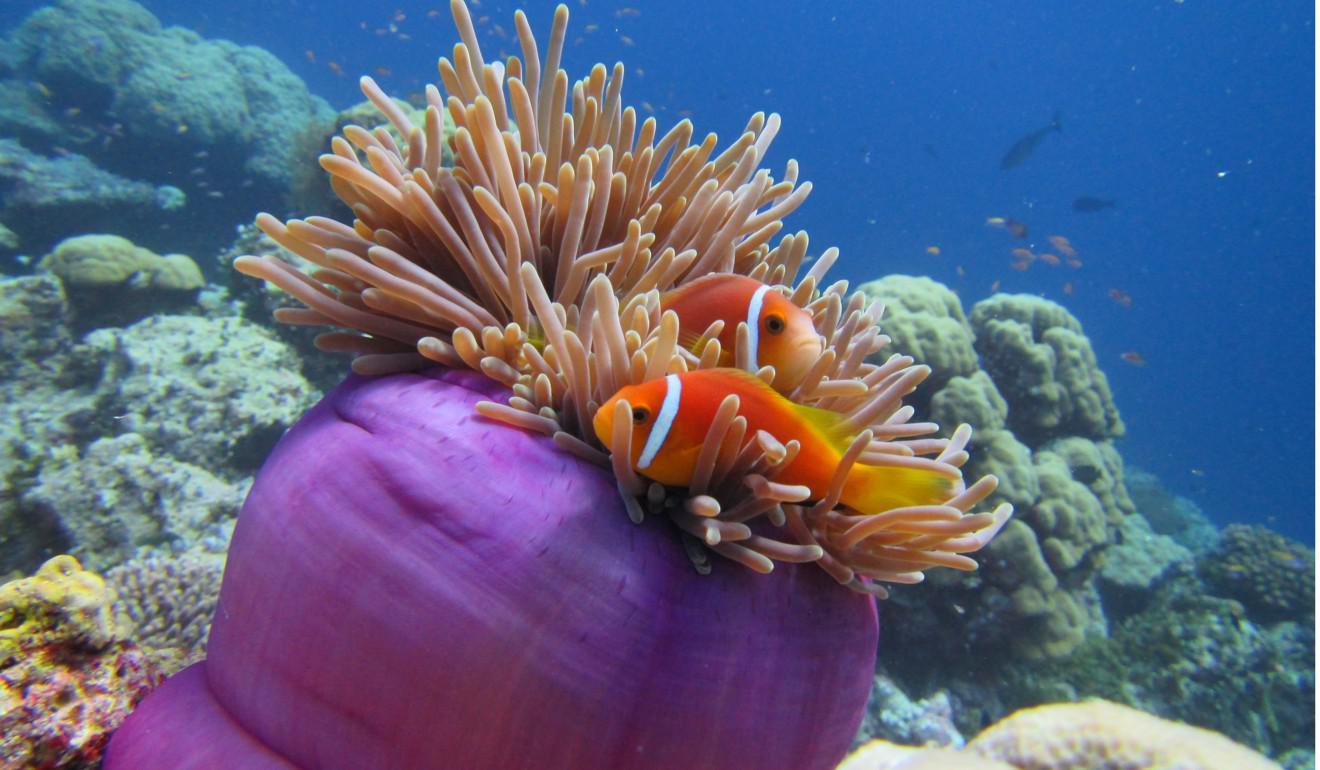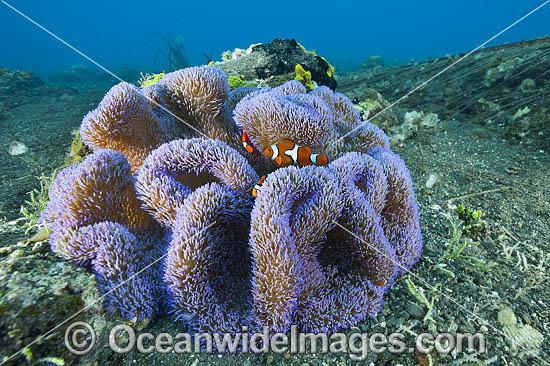The first image is the image on the left, the second image is the image on the right. For the images displayed, is the sentence "One image shows tendrils emerging from a vivid violet 'stalk', and the other image includes orange fish with three white stripes swimming near tendrils that are not neutral colored." factually correct? Answer yes or no. Yes. 